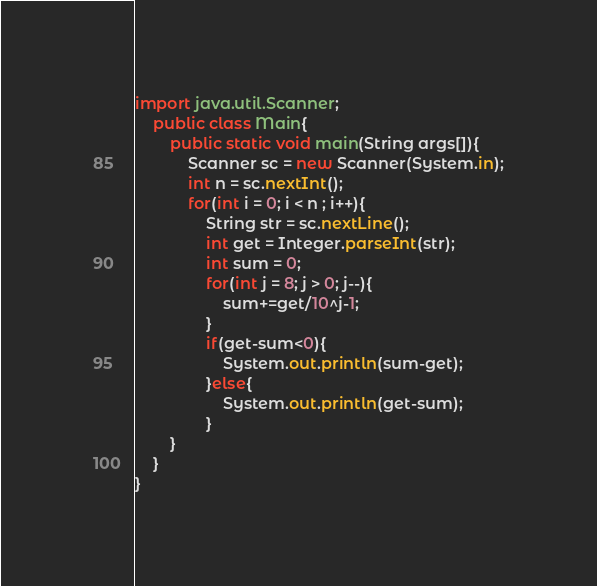<code> <loc_0><loc_0><loc_500><loc_500><_Java_>import java.util.Scanner;
	public class Main{
		public static void main(String args[]){
			Scanner sc = new Scanner(System.in);
			int n = sc.nextInt();
			for(int i = 0; i < n ; i++){
				String str = sc.nextLine();
				int get = Integer.parseInt(str);
				int sum = 0;
				for(int j = 8; j > 0; j--){
					sum+=get/10^j-1;
				}
				if(get-sum<0){
					System.out.println(sum-get);
				}else{
					System.out.println(get-sum);
				}
		}	
	}
}</code> 